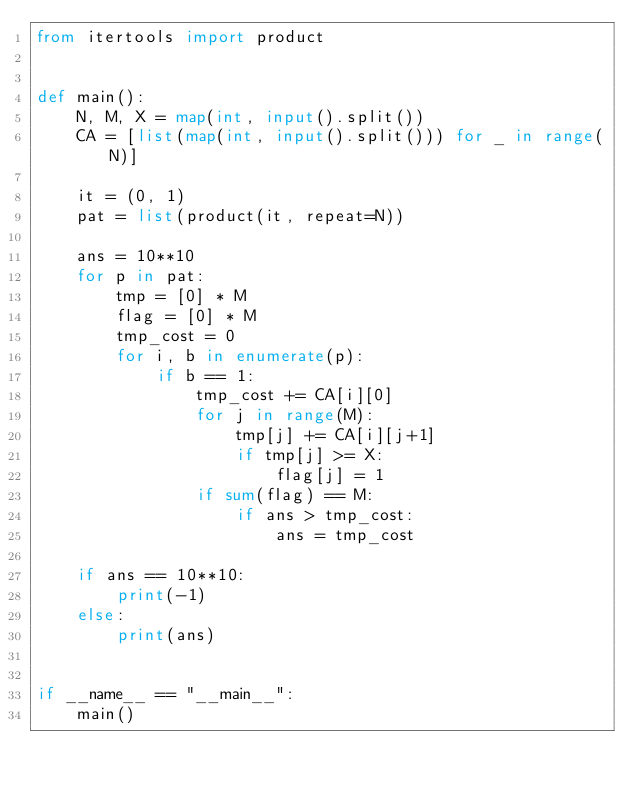<code> <loc_0><loc_0><loc_500><loc_500><_Python_>from itertools import product


def main():
    N, M, X = map(int, input().split())
    CA = [list(map(int, input().split())) for _ in range(N)]

    it = (0, 1)
    pat = list(product(it, repeat=N))

    ans = 10**10
    for p in pat:
        tmp = [0] * M
        flag = [0] * M
        tmp_cost = 0
        for i, b in enumerate(p):
            if b == 1:
                tmp_cost += CA[i][0]
                for j in range(M):
                    tmp[j] += CA[i][j+1]
                    if tmp[j] >= X:
                        flag[j] = 1
                if sum(flag) == M:
                    if ans > tmp_cost:
                        ans = tmp_cost

    if ans == 10**10:
        print(-1)
    else:
        print(ans)


if __name__ == "__main__":
    main()
</code> 